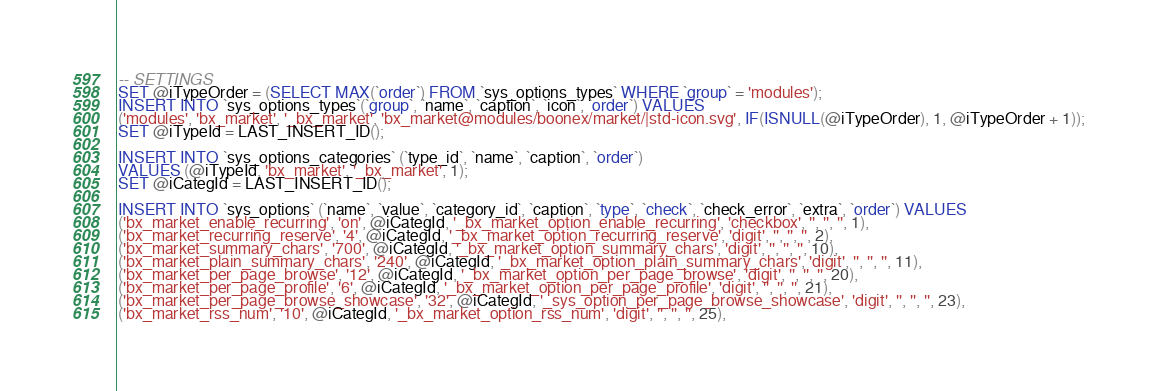<code> <loc_0><loc_0><loc_500><loc_500><_SQL_>
-- SETTINGS
SET @iTypeOrder = (SELECT MAX(`order`) FROM `sys_options_types` WHERE `group` = 'modules');
INSERT INTO `sys_options_types`(`group`, `name`, `caption`, `icon`, `order`) VALUES 
('modules', 'bx_market', '_bx_market', 'bx_market@modules/boonex/market/|std-icon.svg', IF(ISNULL(@iTypeOrder), 1, @iTypeOrder + 1));
SET @iTypeId = LAST_INSERT_ID();

INSERT INTO `sys_options_categories` (`type_id`, `name`, `caption`, `order`)
VALUES (@iTypeId, 'bx_market', '_bx_market', 1);
SET @iCategId = LAST_INSERT_ID();

INSERT INTO `sys_options` (`name`, `value`, `category_id`, `caption`, `type`, `check`, `check_error`, `extra`, `order`) VALUES
('bx_market_enable_recurring', 'on', @iCategId, '_bx_market_option_enable_recurring', 'checkbox', '', '', '', 1),
('bx_market_recurring_reserve', '4', @iCategId, '_bx_market_option_recurring_reserve', 'digit', '', '', '', 2),
('bx_market_summary_chars', '700', @iCategId, '_bx_market_option_summary_chars', 'digit', '', '', '', 10),
('bx_market_plain_summary_chars', '240', @iCategId, '_bx_market_option_plain_summary_chars', 'digit', '', '', '', 11),
('bx_market_per_page_browse', '12', @iCategId, '_bx_market_option_per_page_browse', 'digit', '', '', '', 20),
('bx_market_per_page_profile', '6', @iCategId, '_bx_market_option_per_page_profile', 'digit', '', '', '', 21),
('bx_market_per_page_browse_showcase', '32', @iCategId, '_sys_option_per_page_browse_showcase', 'digit', '', '', '', 23),
('bx_market_rss_num', '10', @iCategId, '_bx_market_option_rss_num', 'digit', '', '', '', 25),</code> 